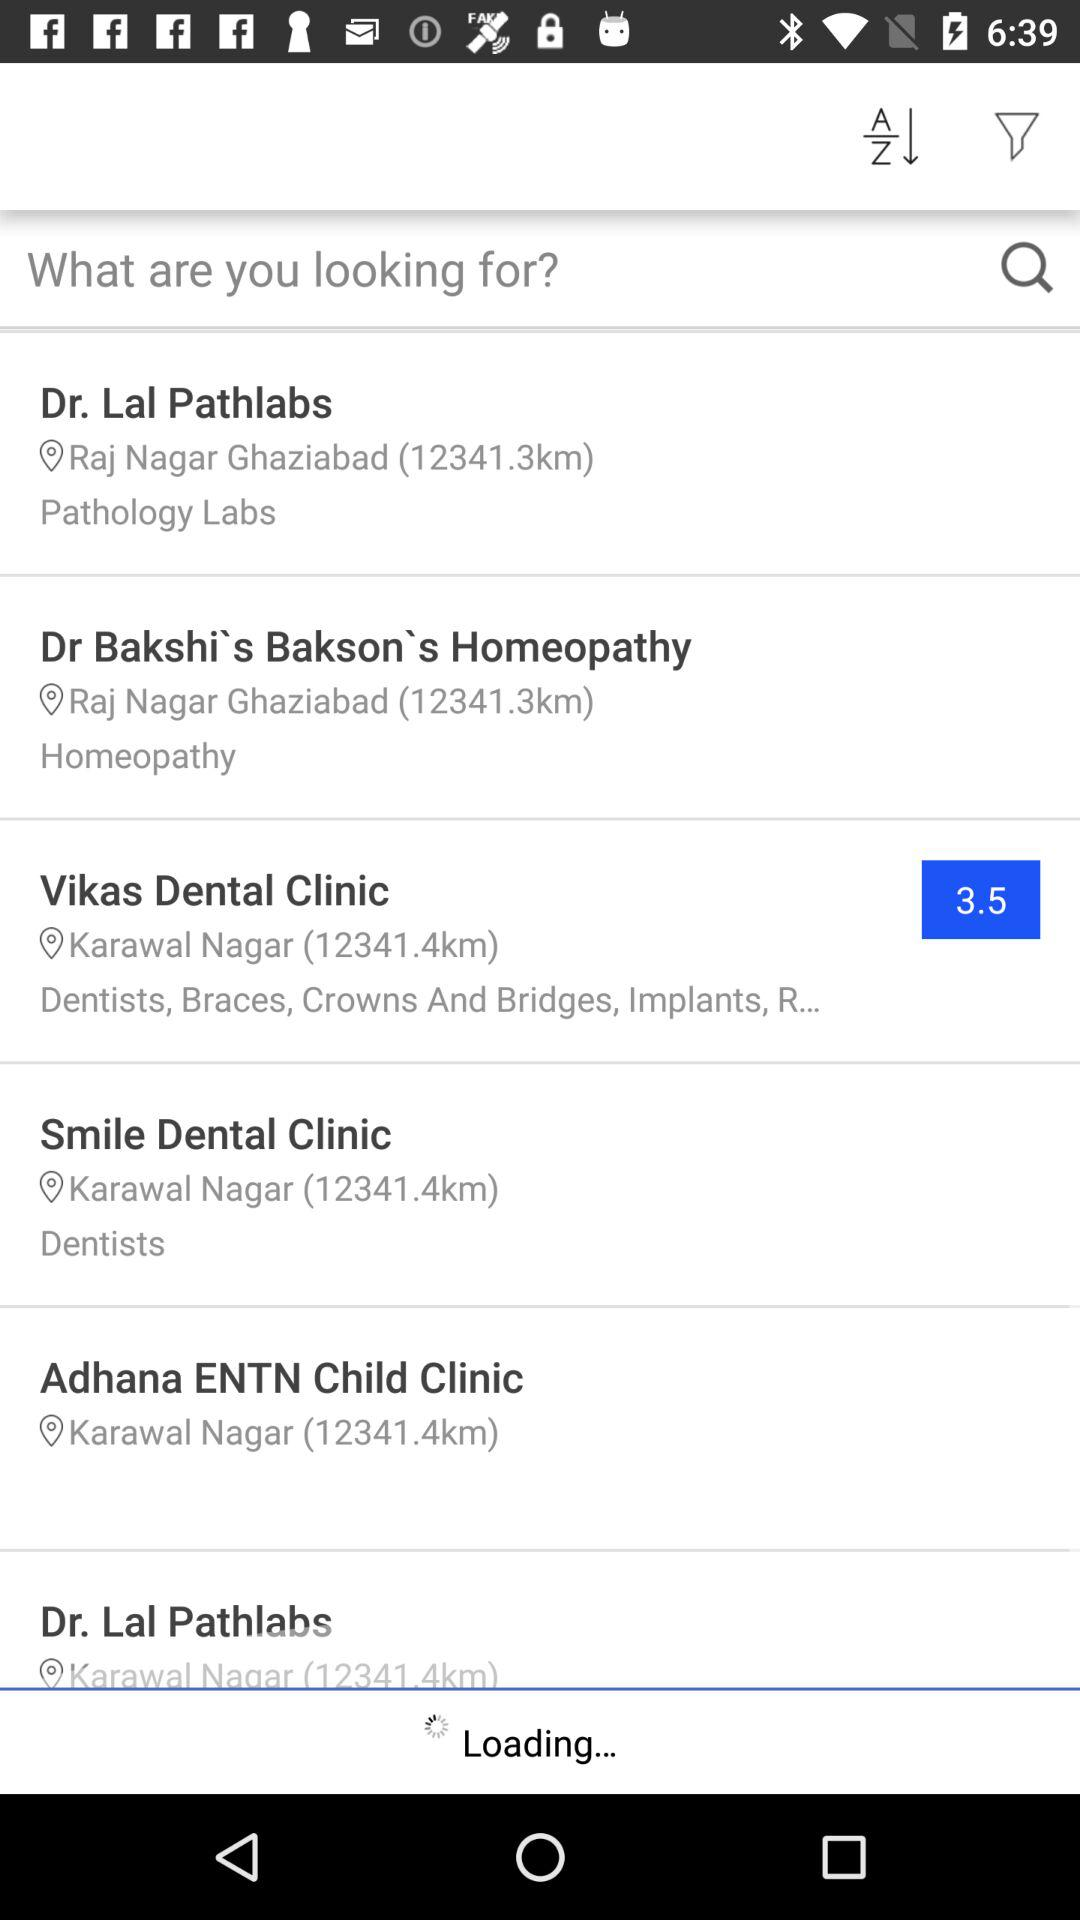What is the distance given for "Dr. Lal Pathlabs"? The given distance is 12341.3 km. 